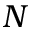<formula> <loc_0><loc_0><loc_500><loc_500>N</formula> 